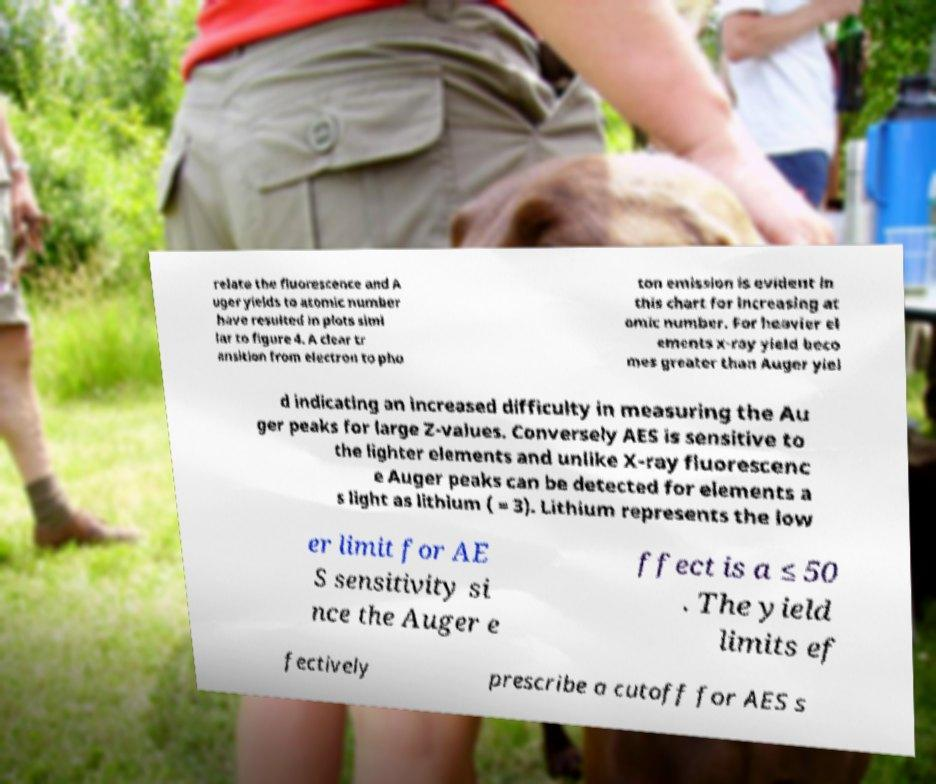I need the written content from this picture converted into text. Can you do that? relate the fluorescence and A uger yields to atomic number have resulted in plots simi lar to figure 4. A clear tr ansition from electron to pho ton emission is evident in this chart for increasing at omic number. For heavier el ements x-ray yield beco mes greater than Auger yiel d indicating an increased difficulty in measuring the Au ger peaks for large Z-values. Conversely AES is sensitive to the lighter elements and unlike X-ray fluorescenc e Auger peaks can be detected for elements a s light as lithium ( = 3). Lithium represents the low er limit for AE S sensitivity si nce the Auger e ffect is a ≤ 50 . The yield limits ef fectively prescribe a cutoff for AES s 